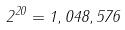<formula> <loc_0><loc_0><loc_500><loc_500>2 ^ { 2 0 } = 1 , 0 4 8 , 5 7 6</formula> 